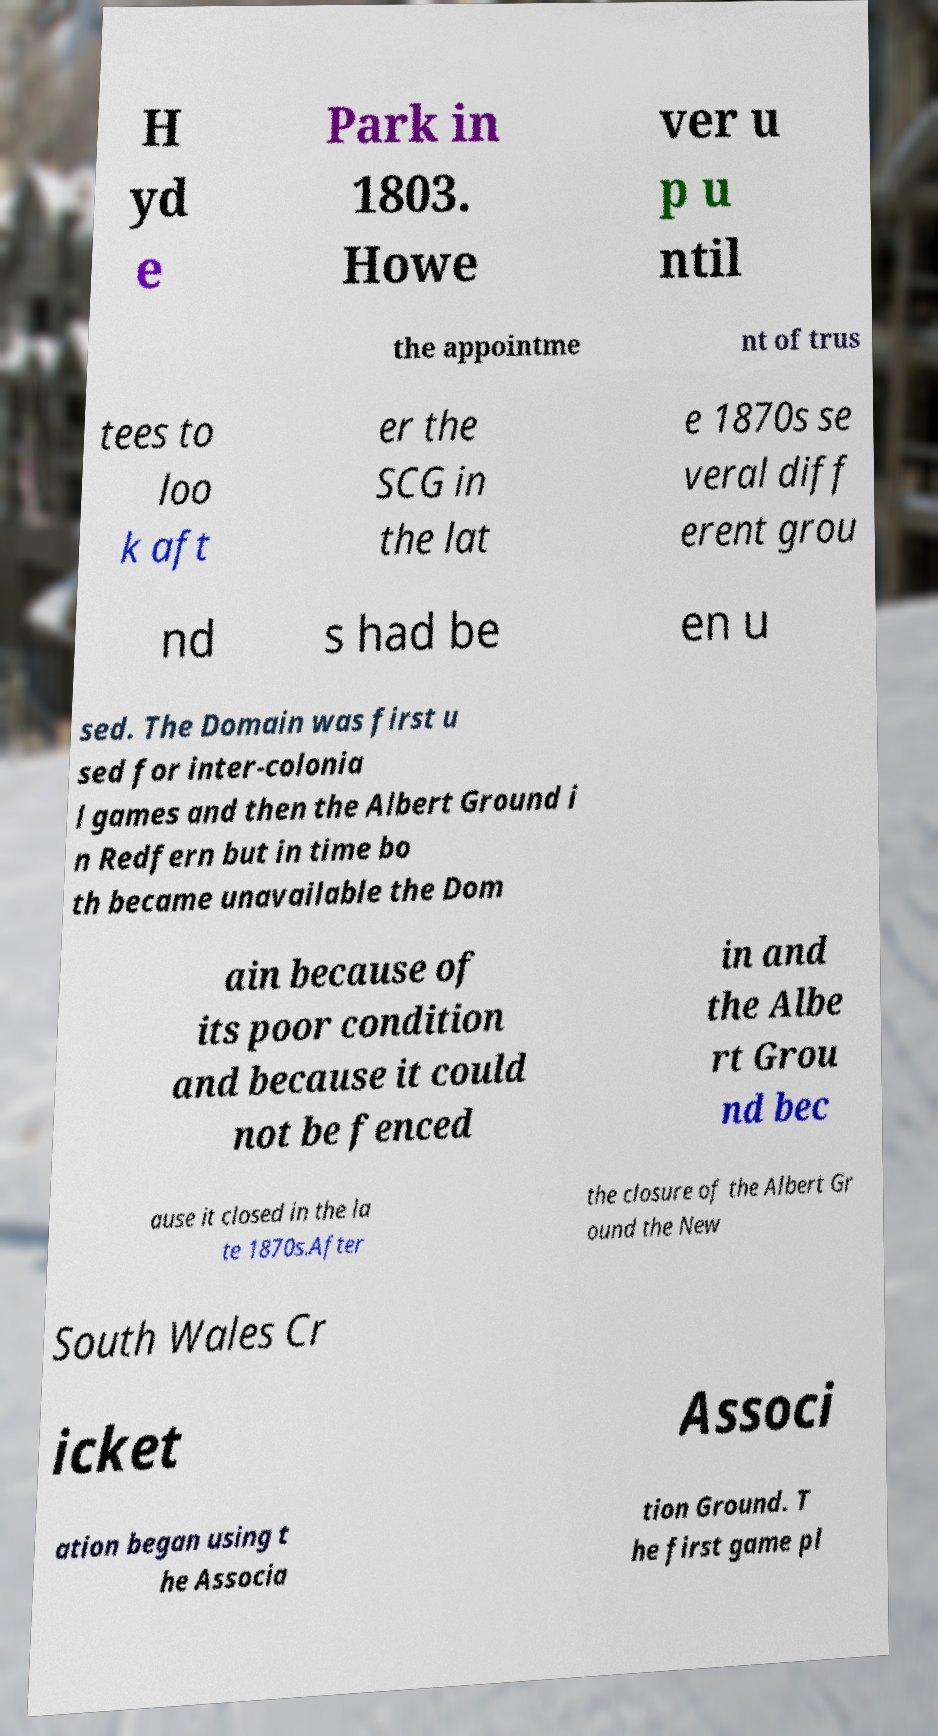For documentation purposes, I need the text within this image transcribed. Could you provide that? H yd e Park in 1803. Howe ver u p u ntil the appointme nt of trus tees to loo k aft er the SCG in the lat e 1870s se veral diff erent grou nd s had be en u sed. The Domain was first u sed for inter-colonia l games and then the Albert Ground i n Redfern but in time bo th became unavailable the Dom ain because of its poor condition and because it could not be fenced in and the Albe rt Grou nd bec ause it closed in the la te 1870s.After the closure of the Albert Gr ound the New South Wales Cr icket Associ ation began using t he Associa tion Ground. T he first game pl 